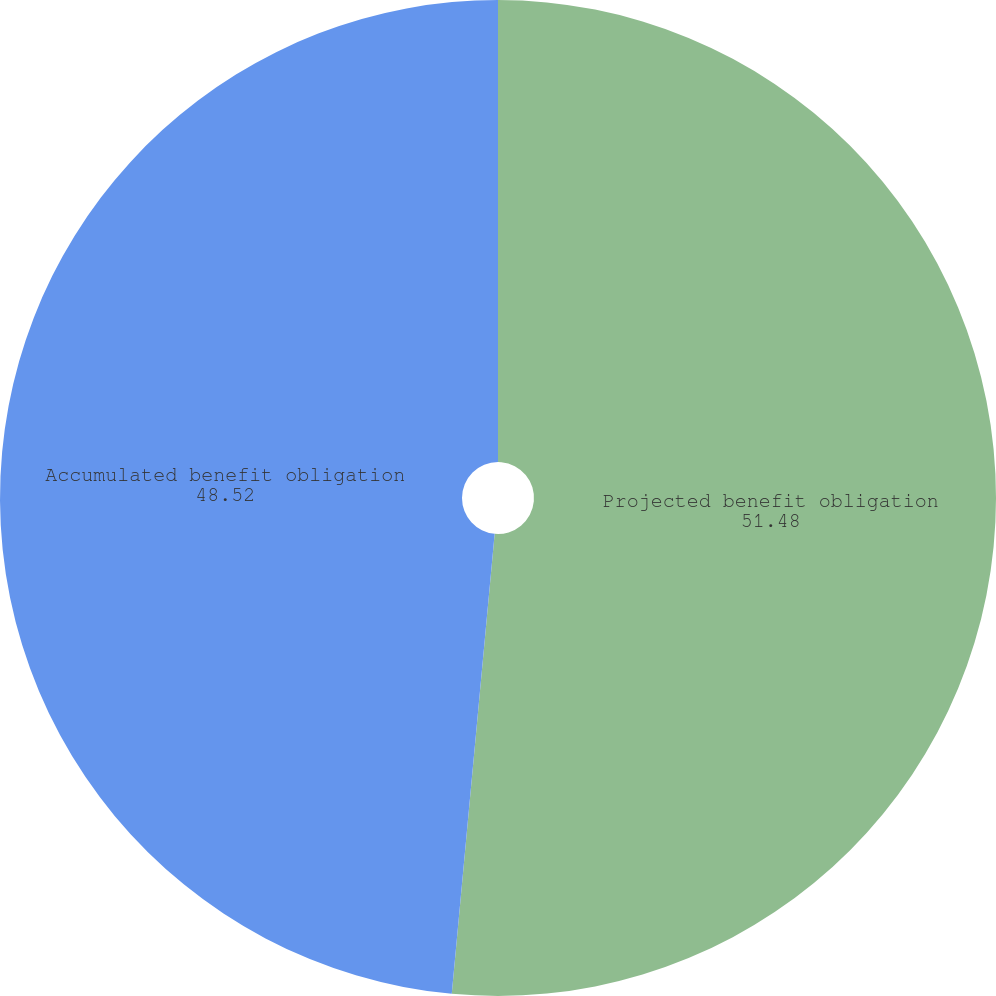Convert chart. <chart><loc_0><loc_0><loc_500><loc_500><pie_chart><fcel>Projected benefit obligation<fcel>Accumulated benefit obligation<nl><fcel>51.48%<fcel>48.52%<nl></chart> 